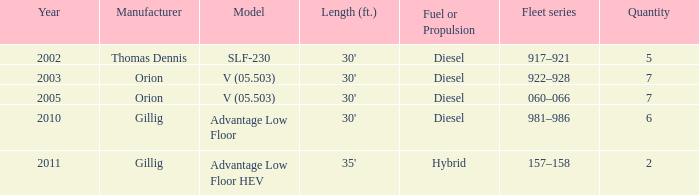Identify the model with diesel-based fuel or propulsion made by the orion manufacturer in 200 V (05.503). Can you give me this table as a dict? {'header': ['Year', 'Manufacturer', 'Model', 'Length (ft.)', 'Fuel or Propulsion', 'Fleet series', 'Quantity'], 'rows': [['2002', 'Thomas Dennis', 'SLF-230', "30'", 'Diesel', '917–921', '5'], ['2003', 'Orion', 'V (05.503)', "30'", 'Diesel', '922–928', '7'], ['2005', 'Orion', 'V (05.503)', "30'", 'Diesel', '060–066', '7'], ['2010', 'Gillig', 'Advantage Low Floor', "30'", 'Diesel', '981–986', '6'], ['2011', 'Gillig', 'Advantage Low Floor HEV', "35'", 'Hybrid', '157–158', '2']]} 